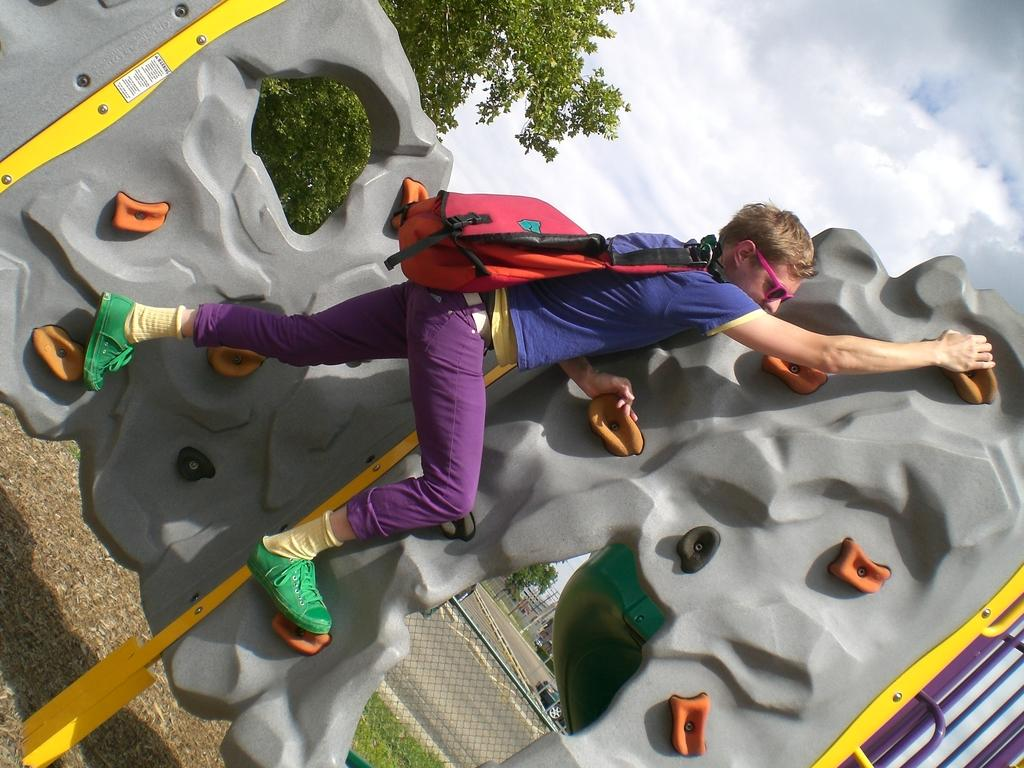What is the main subject of the picture? The main subject of the picture is a boy. What is the boy wearing? The boy is wearing a blue t-shirt and purple jeans. What activity is the boy engaged in? The boy is climbing on an artificial mountain. What can be seen in the background of the image? There is a net grill and trees in the background of the image. What type of bun is the boy holding in the image? There is no bun present in the image; the boy is climbing on an artificial mountain. How does the boy avoid getting stuck in the quicksand while climbing the mountain? There is no quicksand present in the image; the boy is climbing on an artificial mountain. 